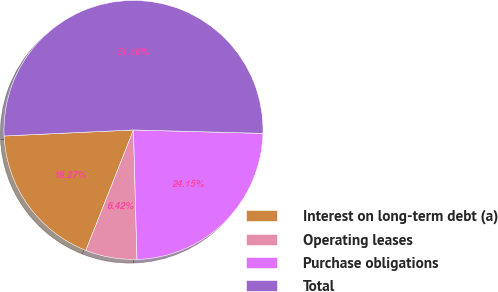Convert chart to OTSL. <chart><loc_0><loc_0><loc_500><loc_500><pie_chart><fcel>Interest on long-term debt (a)<fcel>Operating leases<fcel>Purchase obligations<fcel>Total<nl><fcel>18.27%<fcel>6.42%<fcel>24.15%<fcel>51.16%<nl></chart> 